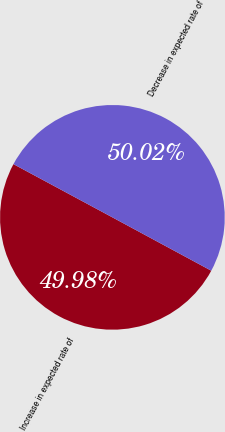<chart> <loc_0><loc_0><loc_500><loc_500><pie_chart><fcel>Increase in expected rate of<fcel>Decrease in expected rate of<nl><fcel>49.98%<fcel>50.02%<nl></chart> 